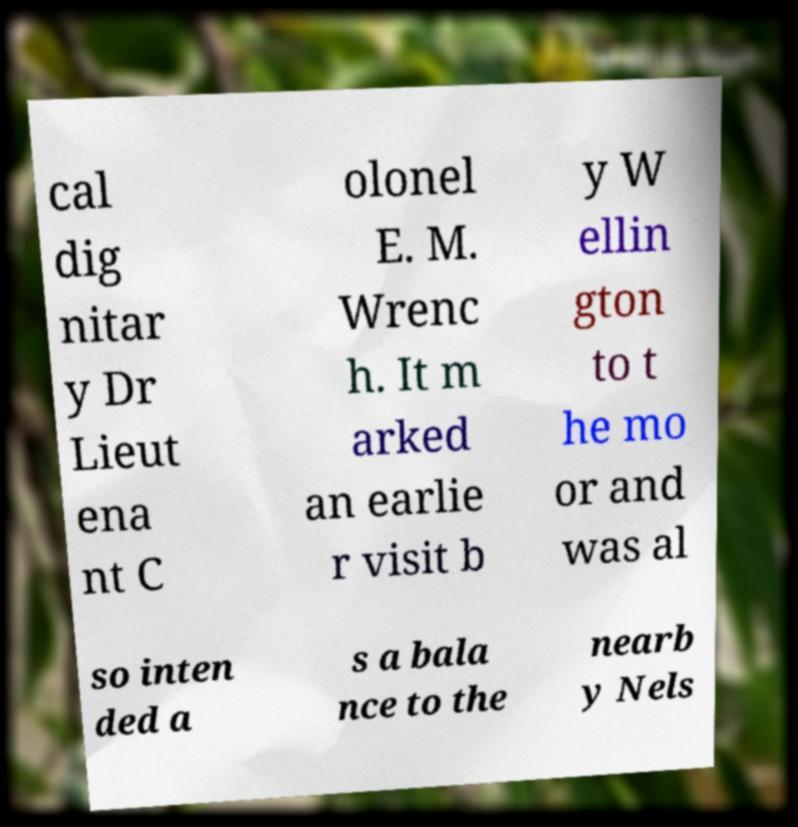Please read and relay the text visible in this image. What does it say? cal dig nitar y Dr Lieut ena nt C olonel E. M. Wrenc h. It m arked an earlie r visit b y W ellin gton to t he mo or and was al so inten ded a s a bala nce to the nearb y Nels 